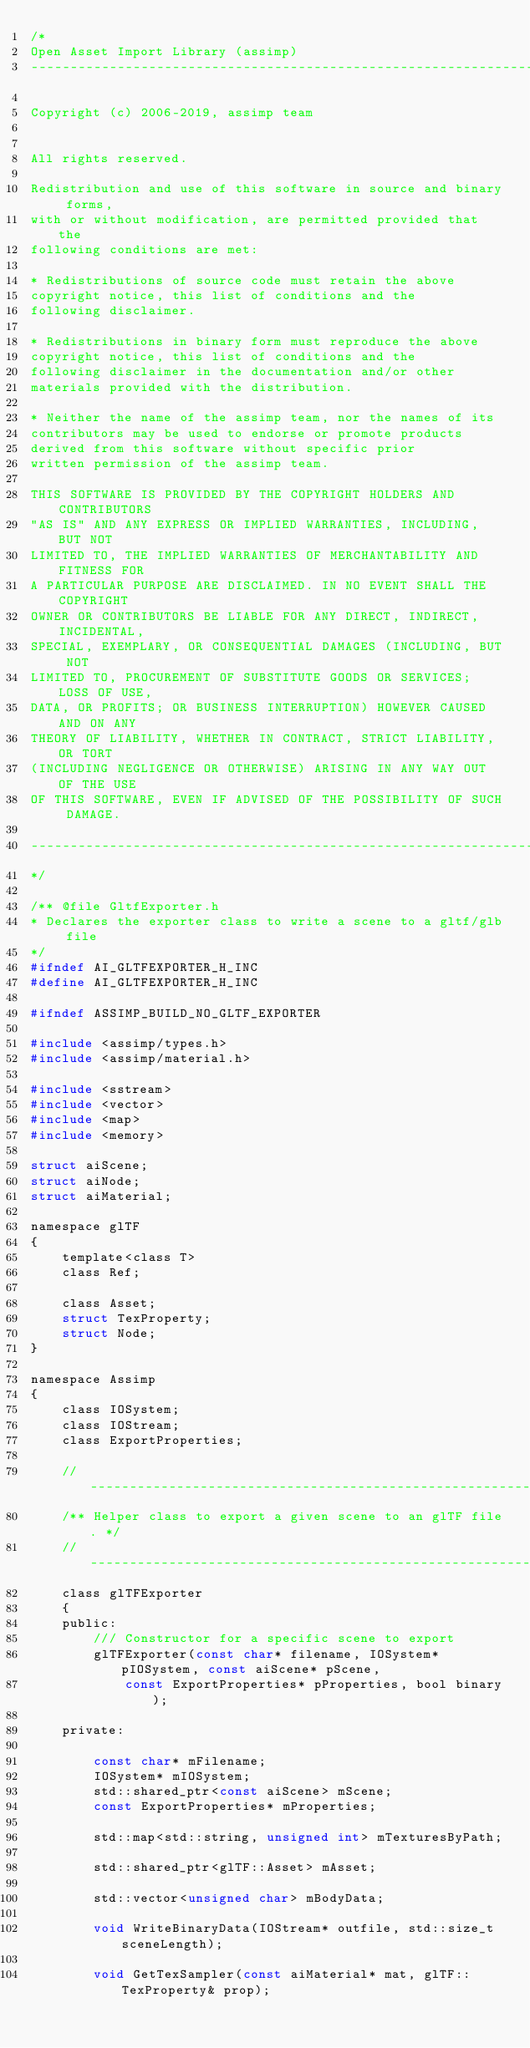<code> <loc_0><loc_0><loc_500><loc_500><_C_>/*
Open Asset Import Library (assimp)
----------------------------------------------------------------------

Copyright (c) 2006-2019, assimp team


All rights reserved.

Redistribution and use of this software in source and binary forms,
with or without modification, are permitted provided that the
following conditions are met:

* Redistributions of source code must retain the above
copyright notice, this list of conditions and the
following disclaimer.

* Redistributions in binary form must reproduce the above
copyright notice, this list of conditions and the
following disclaimer in the documentation and/or other
materials provided with the distribution.

* Neither the name of the assimp team, nor the names of its
contributors may be used to endorse or promote products
derived from this software without specific prior
written permission of the assimp team.

THIS SOFTWARE IS PROVIDED BY THE COPYRIGHT HOLDERS AND CONTRIBUTORS
"AS IS" AND ANY EXPRESS OR IMPLIED WARRANTIES, INCLUDING, BUT NOT
LIMITED TO, THE IMPLIED WARRANTIES OF MERCHANTABILITY AND FITNESS FOR
A PARTICULAR PURPOSE ARE DISCLAIMED. IN NO EVENT SHALL THE COPYRIGHT
OWNER OR CONTRIBUTORS BE LIABLE FOR ANY DIRECT, INDIRECT, INCIDENTAL,
SPECIAL, EXEMPLARY, OR CONSEQUENTIAL DAMAGES (INCLUDING, BUT NOT
LIMITED TO, PROCUREMENT OF SUBSTITUTE GOODS OR SERVICES; LOSS OF USE,
DATA, OR PROFITS; OR BUSINESS INTERRUPTION) HOWEVER CAUSED AND ON ANY
THEORY OF LIABILITY, WHETHER IN CONTRACT, STRICT LIABILITY, OR TORT
(INCLUDING NEGLIGENCE OR OTHERWISE) ARISING IN ANY WAY OUT OF THE USE
OF THIS SOFTWARE, EVEN IF ADVISED OF THE POSSIBILITY OF SUCH DAMAGE.

----------------------------------------------------------------------
*/

/** @file GltfExporter.h
* Declares the exporter class to write a scene to a gltf/glb file
*/
#ifndef AI_GLTFEXPORTER_H_INC
#define AI_GLTFEXPORTER_H_INC

#ifndef ASSIMP_BUILD_NO_GLTF_EXPORTER

#include <assimp/types.h>
#include <assimp/material.h>

#include <sstream>
#include <vector>
#include <map>
#include <memory>

struct aiScene;
struct aiNode;
struct aiMaterial;

namespace glTF
{
    template<class T>
    class Ref;

    class Asset;
    struct TexProperty;
    struct Node;
}

namespace Assimp
{
    class IOSystem;
    class IOStream;
    class ExportProperties;

    // ------------------------------------------------------------------------------------------------
    /** Helper class to export a given scene to an glTF file. */
    // ------------------------------------------------------------------------------------------------
    class glTFExporter
    {
    public:
        /// Constructor for a specific scene to export
        glTFExporter(const char* filename, IOSystem* pIOSystem, const aiScene* pScene,
            const ExportProperties* pProperties, bool binary);

    private:

        const char* mFilename;
        IOSystem* mIOSystem;
        std::shared_ptr<const aiScene> mScene;
        const ExportProperties* mProperties;

        std::map<std::string, unsigned int> mTexturesByPath;

        std::shared_ptr<glTF::Asset> mAsset;

        std::vector<unsigned char> mBodyData;

        void WriteBinaryData(IOStream* outfile, std::size_t sceneLength);

        void GetTexSampler(const aiMaterial* mat, glTF::TexProperty& prop);</code> 